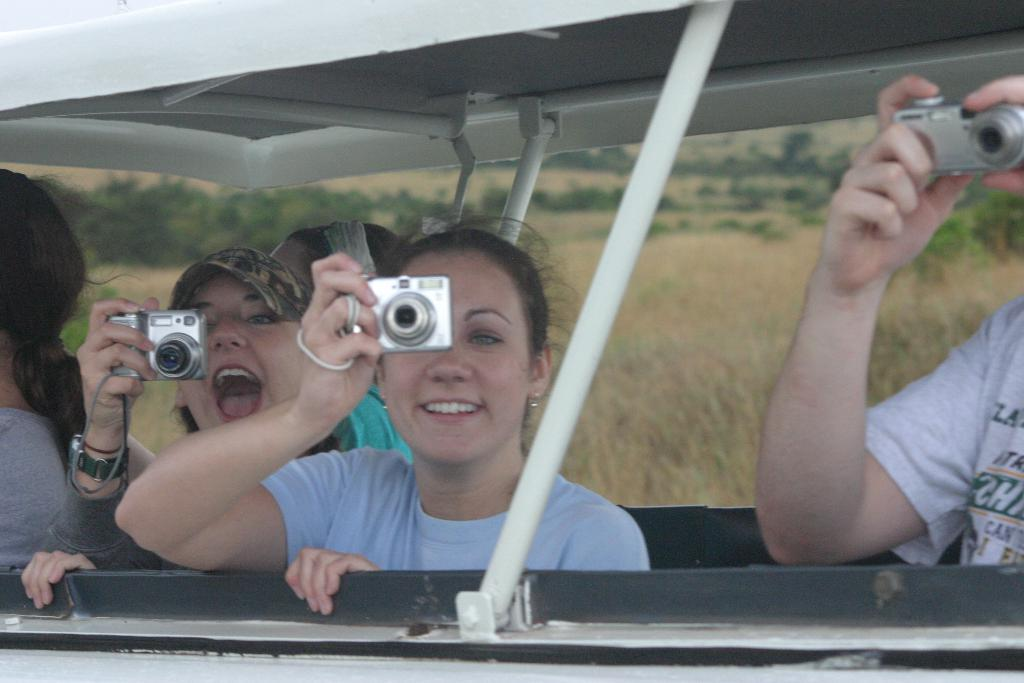What is the main subject of the image? There is a vehicle in the image. Who or what is inside the vehicle? There are people in the vehicle. What are some of the people doing in the image? Some people are holding cameras in their hands. What type of natural environment can be seen in the image? There is grassland visible in the image, and there are trees in the grassland. What type of thread is being used to protest in the image? There is no protest or thread present in the image. The image features a vehicle with people inside, some of whom are holding cameras, and a grassland with trees. 